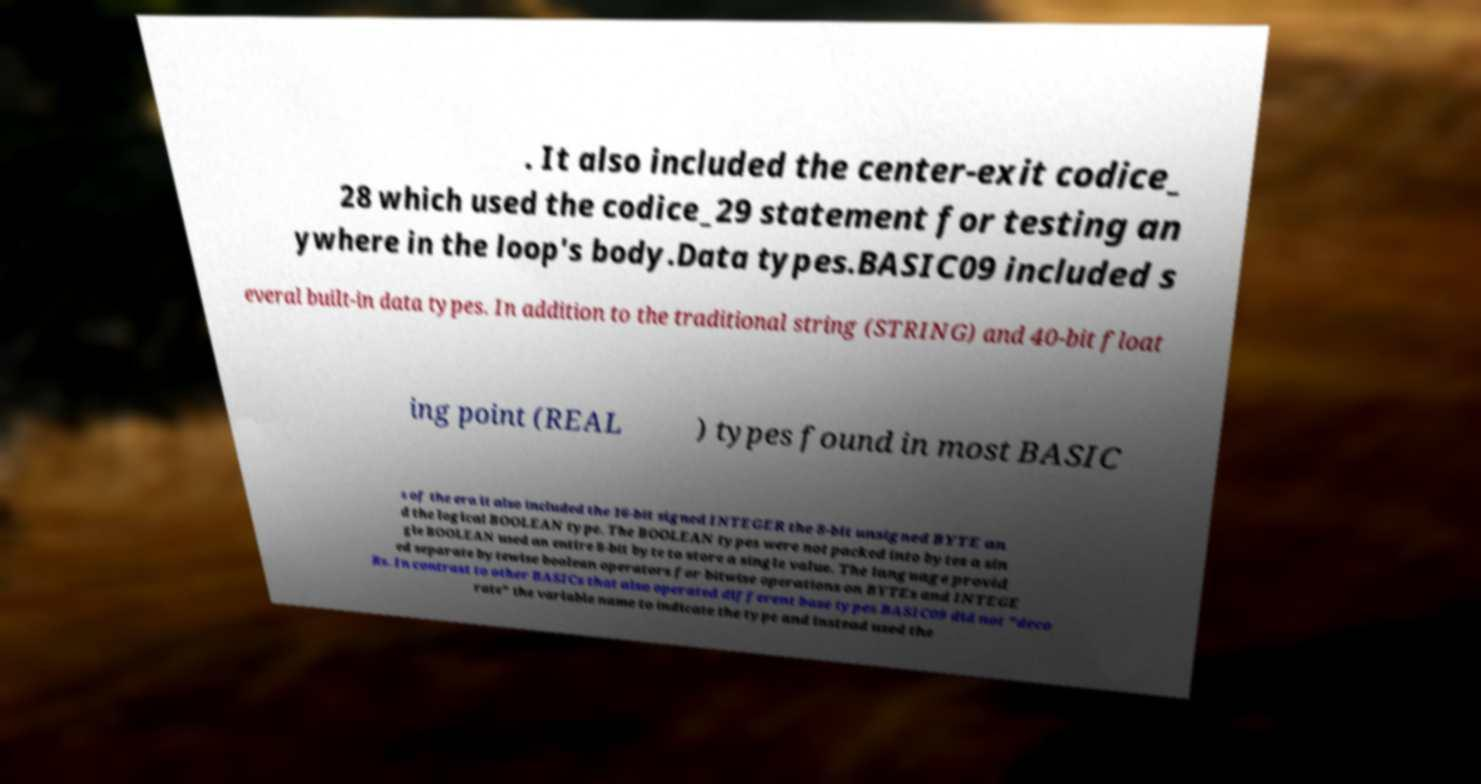Could you extract and type out the text from this image? . It also included the center-exit codice_ 28 which used the codice_29 statement for testing an ywhere in the loop's body.Data types.BASIC09 included s everal built-in data types. In addition to the traditional string (STRING) and 40-bit float ing point (REAL ) types found in most BASIC s of the era it also included the 16-bit signed INTEGER the 8-bit unsigned BYTE an d the logical BOOLEAN type. The BOOLEAN types were not packed into bytes a sin gle BOOLEAN used an entire 8-bit byte to store a single value. The language provid ed separate bytewise boolean operators for bitwise operations on BYTEs and INTEGE Rs. In contrast to other BASICs that also operated different base types BASIC09 did not "deco rate" the variable name to indicate the type and instead used the 